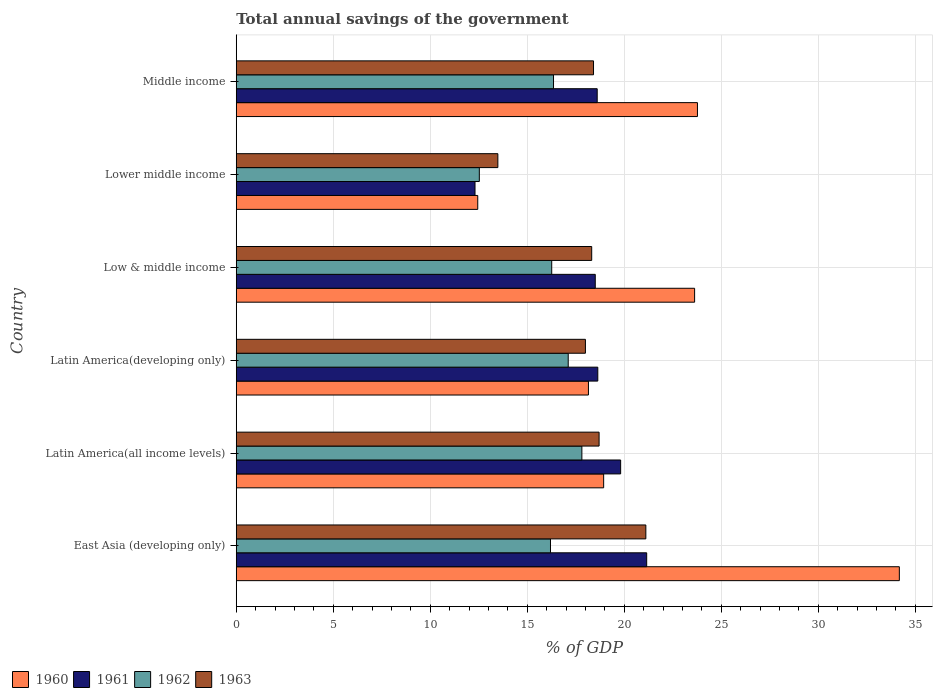How many different coloured bars are there?
Give a very brief answer. 4. How many groups of bars are there?
Offer a very short reply. 6. Are the number of bars on each tick of the Y-axis equal?
Offer a very short reply. Yes. How many bars are there on the 5th tick from the bottom?
Keep it short and to the point. 4. What is the label of the 1st group of bars from the top?
Your answer should be compact. Middle income. What is the total annual savings of the government in 1963 in East Asia (developing only)?
Your answer should be compact. 21.11. Across all countries, what is the maximum total annual savings of the government in 1960?
Give a very brief answer. 34.17. Across all countries, what is the minimum total annual savings of the government in 1960?
Give a very brief answer. 12.45. In which country was the total annual savings of the government in 1962 maximum?
Provide a succinct answer. Latin America(all income levels). In which country was the total annual savings of the government in 1962 minimum?
Make the answer very short. Lower middle income. What is the total total annual savings of the government in 1960 in the graph?
Offer a very short reply. 131.09. What is the difference between the total annual savings of the government in 1963 in Latin America(developing only) and that in Low & middle income?
Your answer should be compact. -0.32. What is the difference between the total annual savings of the government in 1960 in Middle income and the total annual savings of the government in 1962 in Low & middle income?
Make the answer very short. 7.51. What is the average total annual savings of the government in 1961 per country?
Provide a succinct answer. 18.17. What is the difference between the total annual savings of the government in 1961 and total annual savings of the government in 1960 in Low & middle income?
Make the answer very short. -5.12. In how many countries, is the total annual savings of the government in 1961 greater than 17 %?
Offer a very short reply. 5. What is the ratio of the total annual savings of the government in 1960 in Latin America(all income levels) to that in Latin America(developing only)?
Your response must be concise. 1.04. What is the difference between the highest and the second highest total annual savings of the government in 1961?
Ensure brevity in your answer.  1.34. What is the difference between the highest and the lowest total annual savings of the government in 1960?
Your response must be concise. 21.73. Is it the case that in every country, the sum of the total annual savings of the government in 1960 and total annual savings of the government in 1961 is greater than the sum of total annual savings of the government in 1962 and total annual savings of the government in 1963?
Provide a short and direct response. No. What does the 3rd bar from the top in East Asia (developing only) represents?
Ensure brevity in your answer.  1961. What does the 4th bar from the bottom in Latin America(all income levels) represents?
Your answer should be very brief. 1963. Does the graph contain any zero values?
Give a very brief answer. No. How are the legend labels stacked?
Your answer should be very brief. Horizontal. What is the title of the graph?
Offer a very short reply. Total annual savings of the government. Does "1995" appear as one of the legend labels in the graph?
Give a very brief answer. No. What is the label or title of the X-axis?
Provide a short and direct response. % of GDP. What is the label or title of the Y-axis?
Provide a succinct answer. Country. What is the % of GDP of 1960 in East Asia (developing only)?
Make the answer very short. 34.17. What is the % of GDP of 1961 in East Asia (developing only)?
Your response must be concise. 21.15. What is the % of GDP of 1962 in East Asia (developing only)?
Ensure brevity in your answer.  16.19. What is the % of GDP of 1963 in East Asia (developing only)?
Give a very brief answer. 21.11. What is the % of GDP of 1960 in Latin America(all income levels)?
Provide a short and direct response. 18.93. What is the % of GDP in 1961 in Latin America(all income levels)?
Offer a terse response. 19.81. What is the % of GDP of 1962 in Latin America(all income levels)?
Make the answer very short. 17.81. What is the % of GDP in 1963 in Latin America(all income levels)?
Offer a very short reply. 18.7. What is the % of GDP of 1960 in Latin America(developing only)?
Give a very brief answer. 18.15. What is the % of GDP in 1961 in Latin America(developing only)?
Ensure brevity in your answer.  18.63. What is the % of GDP of 1962 in Latin America(developing only)?
Offer a terse response. 17.11. What is the % of GDP in 1963 in Latin America(developing only)?
Your answer should be very brief. 17.99. What is the % of GDP of 1960 in Low & middle income?
Give a very brief answer. 23.62. What is the % of GDP of 1961 in Low & middle income?
Your answer should be very brief. 18.5. What is the % of GDP of 1962 in Low & middle income?
Offer a terse response. 16.26. What is the % of GDP of 1963 in Low & middle income?
Give a very brief answer. 18.32. What is the % of GDP in 1960 in Lower middle income?
Make the answer very short. 12.45. What is the % of GDP of 1961 in Lower middle income?
Make the answer very short. 12.3. What is the % of GDP in 1962 in Lower middle income?
Make the answer very short. 12.53. What is the % of GDP of 1963 in Lower middle income?
Offer a terse response. 13.48. What is the % of GDP of 1960 in Middle income?
Offer a terse response. 23.77. What is the % of GDP of 1961 in Middle income?
Your answer should be compact. 18.6. What is the % of GDP in 1962 in Middle income?
Offer a terse response. 16.35. What is the % of GDP in 1963 in Middle income?
Your answer should be compact. 18.41. Across all countries, what is the maximum % of GDP in 1960?
Provide a succinct answer. 34.17. Across all countries, what is the maximum % of GDP of 1961?
Provide a succinct answer. 21.15. Across all countries, what is the maximum % of GDP in 1962?
Provide a succinct answer. 17.81. Across all countries, what is the maximum % of GDP of 1963?
Give a very brief answer. 21.11. Across all countries, what is the minimum % of GDP in 1960?
Provide a short and direct response. 12.45. Across all countries, what is the minimum % of GDP in 1961?
Your answer should be very brief. 12.3. Across all countries, what is the minimum % of GDP in 1962?
Your response must be concise. 12.53. Across all countries, what is the minimum % of GDP in 1963?
Ensure brevity in your answer.  13.48. What is the total % of GDP of 1960 in the graph?
Give a very brief answer. 131.09. What is the total % of GDP of 1961 in the graph?
Your answer should be very brief. 109. What is the total % of GDP in 1962 in the graph?
Offer a terse response. 96.25. What is the total % of GDP of 1963 in the graph?
Ensure brevity in your answer.  108.02. What is the difference between the % of GDP of 1960 in East Asia (developing only) and that in Latin America(all income levels)?
Provide a short and direct response. 15.24. What is the difference between the % of GDP in 1961 in East Asia (developing only) and that in Latin America(all income levels)?
Your answer should be very brief. 1.34. What is the difference between the % of GDP of 1962 in East Asia (developing only) and that in Latin America(all income levels)?
Provide a short and direct response. -1.62. What is the difference between the % of GDP of 1963 in East Asia (developing only) and that in Latin America(all income levels)?
Provide a succinct answer. 2.41. What is the difference between the % of GDP in 1960 in East Asia (developing only) and that in Latin America(developing only)?
Your response must be concise. 16.02. What is the difference between the % of GDP in 1961 in East Asia (developing only) and that in Latin America(developing only)?
Keep it short and to the point. 2.52. What is the difference between the % of GDP of 1962 in East Asia (developing only) and that in Latin America(developing only)?
Your answer should be compact. -0.91. What is the difference between the % of GDP in 1963 in East Asia (developing only) and that in Latin America(developing only)?
Provide a succinct answer. 3.11. What is the difference between the % of GDP of 1960 in East Asia (developing only) and that in Low & middle income?
Ensure brevity in your answer.  10.55. What is the difference between the % of GDP in 1961 in East Asia (developing only) and that in Low & middle income?
Your response must be concise. 2.65. What is the difference between the % of GDP in 1962 in East Asia (developing only) and that in Low & middle income?
Ensure brevity in your answer.  -0.06. What is the difference between the % of GDP of 1963 in East Asia (developing only) and that in Low & middle income?
Your answer should be compact. 2.79. What is the difference between the % of GDP of 1960 in East Asia (developing only) and that in Lower middle income?
Offer a terse response. 21.73. What is the difference between the % of GDP in 1961 in East Asia (developing only) and that in Lower middle income?
Ensure brevity in your answer.  8.85. What is the difference between the % of GDP in 1962 in East Asia (developing only) and that in Lower middle income?
Ensure brevity in your answer.  3.67. What is the difference between the % of GDP of 1963 in East Asia (developing only) and that in Lower middle income?
Make the answer very short. 7.63. What is the difference between the % of GDP in 1960 in East Asia (developing only) and that in Middle income?
Offer a terse response. 10.4. What is the difference between the % of GDP in 1961 in East Asia (developing only) and that in Middle income?
Ensure brevity in your answer.  2.55. What is the difference between the % of GDP of 1962 in East Asia (developing only) and that in Middle income?
Make the answer very short. -0.16. What is the difference between the % of GDP in 1963 in East Asia (developing only) and that in Middle income?
Your answer should be compact. 2.7. What is the difference between the % of GDP of 1960 in Latin America(all income levels) and that in Latin America(developing only)?
Offer a terse response. 0.78. What is the difference between the % of GDP in 1961 in Latin America(all income levels) and that in Latin America(developing only)?
Keep it short and to the point. 1.18. What is the difference between the % of GDP in 1962 in Latin America(all income levels) and that in Latin America(developing only)?
Offer a very short reply. 0.7. What is the difference between the % of GDP of 1963 in Latin America(all income levels) and that in Latin America(developing only)?
Your answer should be compact. 0.7. What is the difference between the % of GDP in 1960 in Latin America(all income levels) and that in Low & middle income?
Make the answer very short. -4.69. What is the difference between the % of GDP of 1961 in Latin America(all income levels) and that in Low & middle income?
Offer a terse response. 1.31. What is the difference between the % of GDP in 1962 in Latin America(all income levels) and that in Low & middle income?
Your answer should be compact. 1.55. What is the difference between the % of GDP in 1963 in Latin America(all income levels) and that in Low & middle income?
Offer a very short reply. 0.38. What is the difference between the % of GDP in 1960 in Latin America(all income levels) and that in Lower middle income?
Make the answer very short. 6.49. What is the difference between the % of GDP in 1961 in Latin America(all income levels) and that in Lower middle income?
Your answer should be compact. 7.5. What is the difference between the % of GDP in 1962 in Latin America(all income levels) and that in Lower middle income?
Ensure brevity in your answer.  5.28. What is the difference between the % of GDP of 1963 in Latin America(all income levels) and that in Lower middle income?
Your response must be concise. 5.22. What is the difference between the % of GDP of 1960 in Latin America(all income levels) and that in Middle income?
Offer a very short reply. -4.83. What is the difference between the % of GDP in 1961 in Latin America(all income levels) and that in Middle income?
Keep it short and to the point. 1.21. What is the difference between the % of GDP of 1962 in Latin America(all income levels) and that in Middle income?
Your answer should be very brief. 1.46. What is the difference between the % of GDP in 1963 in Latin America(all income levels) and that in Middle income?
Your answer should be very brief. 0.29. What is the difference between the % of GDP in 1960 in Latin America(developing only) and that in Low & middle income?
Your response must be concise. -5.47. What is the difference between the % of GDP of 1961 in Latin America(developing only) and that in Low & middle income?
Provide a short and direct response. 0.13. What is the difference between the % of GDP in 1962 in Latin America(developing only) and that in Low & middle income?
Make the answer very short. 0.85. What is the difference between the % of GDP in 1963 in Latin America(developing only) and that in Low & middle income?
Offer a very short reply. -0.32. What is the difference between the % of GDP of 1960 in Latin America(developing only) and that in Lower middle income?
Give a very brief answer. 5.7. What is the difference between the % of GDP in 1961 in Latin America(developing only) and that in Lower middle income?
Keep it short and to the point. 6.33. What is the difference between the % of GDP in 1962 in Latin America(developing only) and that in Lower middle income?
Your response must be concise. 4.58. What is the difference between the % of GDP in 1963 in Latin America(developing only) and that in Lower middle income?
Offer a terse response. 4.51. What is the difference between the % of GDP of 1960 in Latin America(developing only) and that in Middle income?
Provide a short and direct response. -5.62. What is the difference between the % of GDP in 1961 in Latin America(developing only) and that in Middle income?
Your answer should be very brief. 0.03. What is the difference between the % of GDP of 1962 in Latin America(developing only) and that in Middle income?
Make the answer very short. 0.76. What is the difference between the % of GDP of 1963 in Latin America(developing only) and that in Middle income?
Make the answer very short. -0.42. What is the difference between the % of GDP in 1960 in Low & middle income and that in Lower middle income?
Your answer should be compact. 11.18. What is the difference between the % of GDP in 1961 in Low & middle income and that in Lower middle income?
Offer a terse response. 6.2. What is the difference between the % of GDP in 1962 in Low & middle income and that in Lower middle income?
Your answer should be very brief. 3.73. What is the difference between the % of GDP in 1963 in Low & middle income and that in Lower middle income?
Offer a very short reply. 4.84. What is the difference between the % of GDP in 1960 in Low & middle income and that in Middle income?
Offer a terse response. -0.15. What is the difference between the % of GDP in 1961 in Low & middle income and that in Middle income?
Your response must be concise. -0.1. What is the difference between the % of GDP in 1962 in Low & middle income and that in Middle income?
Provide a short and direct response. -0.09. What is the difference between the % of GDP in 1963 in Low & middle income and that in Middle income?
Give a very brief answer. -0.09. What is the difference between the % of GDP in 1960 in Lower middle income and that in Middle income?
Offer a very short reply. -11.32. What is the difference between the % of GDP of 1961 in Lower middle income and that in Middle income?
Give a very brief answer. -6.3. What is the difference between the % of GDP in 1962 in Lower middle income and that in Middle income?
Provide a short and direct response. -3.82. What is the difference between the % of GDP in 1963 in Lower middle income and that in Middle income?
Give a very brief answer. -4.93. What is the difference between the % of GDP of 1960 in East Asia (developing only) and the % of GDP of 1961 in Latin America(all income levels)?
Offer a very short reply. 14.36. What is the difference between the % of GDP of 1960 in East Asia (developing only) and the % of GDP of 1962 in Latin America(all income levels)?
Make the answer very short. 16.36. What is the difference between the % of GDP of 1960 in East Asia (developing only) and the % of GDP of 1963 in Latin America(all income levels)?
Keep it short and to the point. 15.47. What is the difference between the % of GDP in 1961 in East Asia (developing only) and the % of GDP in 1962 in Latin America(all income levels)?
Offer a very short reply. 3.34. What is the difference between the % of GDP in 1961 in East Asia (developing only) and the % of GDP in 1963 in Latin America(all income levels)?
Your response must be concise. 2.45. What is the difference between the % of GDP in 1962 in East Asia (developing only) and the % of GDP in 1963 in Latin America(all income levels)?
Provide a short and direct response. -2.5. What is the difference between the % of GDP in 1960 in East Asia (developing only) and the % of GDP in 1961 in Latin America(developing only)?
Keep it short and to the point. 15.54. What is the difference between the % of GDP of 1960 in East Asia (developing only) and the % of GDP of 1962 in Latin America(developing only)?
Provide a succinct answer. 17.06. What is the difference between the % of GDP in 1960 in East Asia (developing only) and the % of GDP in 1963 in Latin America(developing only)?
Your answer should be compact. 16.18. What is the difference between the % of GDP in 1961 in East Asia (developing only) and the % of GDP in 1962 in Latin America(developing only)?
Offer a terse response. 4.04. What is the difference between the % of GDP in 1961 in East Asia (developing only) and the % of GDP in 1963 in Latin America(developing only)?
Your answer should be very brief. 3.16. What is the difference between the % of GDP in 1962 in East Asia (developing only) and the % of GDP in 1963 in Latin America(developing only)?
Your response must be concise. -1.8. What is the difference between the % of GDP in 1960 in East Asia (developing only) and the % of GDP in 1961 in Low & middle income?
Provide a succinct answer. 15.67. What is the difference between the % of GDP of 1960 in East Asia (developing only) and the % of GDP of 1962 in Low & middle income?
Provide a short and direct response. 17.91. What is the difference between the % of GDP of 1960 in East Asia (developing only) and the % of GDP of 1963 in Low & middle income?
Your answer should be compact. 15.85. What is the difference between the % of GDP of 1961 in East Asia (developing only) and the % of GDP of 1962 in Low & middle income?
Give a very brief answer. 4.89. What is the difference between the % of GDP in 1961 in East Asia (developing only) and the % of GDP in 1963 in Low & middle income?
Provide a succinct answer. 2.83. What is the difference between the % of GDP in 1962 in East Asia (developing only) and the % of GDP in 1963 in Low & middle income?
Ensure brevity in your answer.  -2.12. What is the difference between the % of GDP of 1960 in East Asia (developing only) and the % of GDP of 1961 in Lower middle income?
Provide a short and direct response. 21.87. What is the difference between the % of GDP of 1960 in East Asia (developing only) and the % of GDP of 1962 in Lower middle income?
Offer a very short reply. 21.65. What is the difference between the % of GDP of 1960 in East Asia (developing only) and the % of GDP of 1963 in Lower middle income?
Provide a short and direct response. 20.69. What is the difference between the % of GDP of 1961 in East Asia (developing only) and the % of GDP of 1962 in Lower middle income?
Your answer should be very brief. 8.62. What is the difference between the % of GDP of 1961 in East Asia (developing only) and the % of GDP of 1963 in Lower middle income?
Your answer should be compact. 7.67. What is the difference between the % of GDP in 1962 in East Asia (developing only) and the % of GDP in 1963 in Lower middle income?
Offer a terse response. 2.71. What is the difference between the % of GDP in 1960 in East Asia (developing only) and the % of GDP in 1961 in Middle income?
Give a very brief answer. 15.57. What is the difference between the % of GDP in 1960 in East Asia (developing only) and the % of GDP in 1962 in Middle income?
Your answer should be very brief. 17.82. What is the difference between the % of GDP in 1960 in East Asia (developing only) and the % of GDP in 1963 in Middle income?
Keep it short and to the point. 15.76. What is the difference between the % of GDP of 1961 in East Asia (developing only) and the % of GDP of 1962 in Middle income?
Your answer should be compact. 4.8. What is the difference between the % of GDP of 1961 in East Asia (developing only) and the % of GDP of 1963 in Middle income?
Your response must be concise. 2.74. What is the difference between the % of GDP of 1962 in East Asia (developing only) and the % of GDP of 1963 in Middle income?
Give a very brief answer. -2.22. What is the difference between the % of GDP in 1960 in Latin America(all income levels) and the % of GDP in 1961 in Latin America(developing only)?
Your response must be concise. 0.3. What is the difference between the % of GDP in 1960 in Latin America(all income levels) and the % of GDP in 1962 in Latin America(developing only)?
Keep it short and to the point. 1.83. What is the difference between the % of GDP of 1960 in Latin America(all income levels) and the % of GDP of 1963 in Latin America(developing only)?
Provide a succinct answer. 0.94. What is the difference between the % of GDP of 1961 in Latin America(all income levels) and the % of GDP of 1962 in Latin America(developing only)?
Ensure brevity in your answer.  2.7. What is the difference between the % of GDP of 1961 in Latin America(all income levels) and the % of GDP of 1963 in Latin America(developing only)?
Give a very brief answer. 1.81. What is the difference between the % of GDP in 1962 in Latin America(all income levels) and the % of GDP in 1963 in Latin America(developing only)?
Make the answer very short. -0.18. What is the difference between the % of GDP in 1960 in Latin America(all income levels) and the % of GDP in 1961 in Low & middle income?
Offer a terse response. 0.43. What is the difference between the % of GDP of 1960 in Latin America(all income levels) and the % of GDP of 1962 in Low & middle income?
Your response must be concise. 2.68. What is the difference between the % of GDP of 1960 in Latin America(all income levels) and the % of GDP of 1963 in Low & middle income?
Your answer should be very brief. 0.62. What is the difference between the % of GDP of 1961 in Latin America(all income levels) and the % of GDP of 1962 in Low & middle income?
Offer a very short reply. 3.55. What is the difference between the % of GDP in 1961 in Latin America(all income levels) and the % of GDP in 1963 in Low & middle income?
Give a very brief answer. 1.49. What is the difference between the % of GDP of 1962 in Latin America(all income levels) and the % of GDP of 1963 in Low & middle income?
Keep it short and to the point. -0.51. What is the difference between the % of GDP of 1960 in Latin America(all income levels) and the % of GDP of 1961 in Lower middle income?
Offer a terse response. 6.63. What is the difference between the % of GDP of 1960 in Latin America(all income levels) and the % of GDP of 1962 in Lower middle income?
Ensure brevity in your answer.  6.41. What is the difference between the % of GDP in 1960 in Latin America(all income levels) and the % of GDP in 1963 in Lower middle income?
Your answer should be very brief. 5.45. What is the difference between the % of GDP in 1961 in Latin America(all income levels) and the % of GDP in 1962 in Lower middle income?
Your response must be concise. 7.28. What is the difference between the % of GDP of 1961 in Latin America(all income levels) and the % of GDP of 1963 in Lower middle income?
Your answer should be very brief. 6.33. What is the difference between the % of GDP in 1962 in Latin America(all income levels) and the % of GDP in 1963 in Lower middle income?
Offer a very short reply. 4.33. What is the difference between the % of GDP of 1960 in Latin America(all income levels) and the % of GDP of 1961 in Middle income?
Offer a very short reply. 0.33. What is the difference between the % of GDP of 1960 in Latin America(all income levels) and the % of GDP of 1962 in Middle income?
Your response must be concise. 2.58. What is the difference between the % of GDP in 1960 in Latin America(all income levels) and the % of GDP in 1963 in Middle income?
Give a very brief answer. 0.52. What is the difference between the % of GDP of 1961 in Latin America(all income levels) and the % of GDP of 1962 in Middle income?
Give a very brief answer. 3.46. What is the difference between the % of GDP in 1961 in Latin America(all income levels) and the % of GDP in 1963 in Middle income?
Make the answer very short. 1.4. What is the difference between the % of GDP of 1962 in Latin America(all income levels) and the % of GDP of 1963 in Middle income?
Provide a succinct answer. -0.6. What is the difference between the % of GDP of 1960 in Latin America(developing only) and the % of GDP of 1961 in Low & middle income?
Give a very brief answer. -0.35. What is the difference between the % of GDP in 1960 in Latin America(developing only) and the % of GDP in 1962 in Low & middle income?
Make the answer very short. 1.89. What is the difference between the % of GDP in 1960 in Latin America(developing only) and the % of GDP in 1963 in Low & middle income?
Provide a short and direct response. -0.17. What is the difference between the % of GDP in 1961 in Latin America(developing only) and the % of GDP in 1962 in Low & middle income?
Give a very brief answer. 2.37. What is the difference between the % of GDP in 1961 in Latin America(developing only) and the % of GDP in 1963 in Low & middle income?
Your answer should be very brief. 0.31. What is the difference between the % of GDP of 1962 in Latin America(developing only) and the % of GDP of 1963 in Low & middle income?
Give a very brief answer. -1.21. What is the difference between the % of GDP in 1960 in Latin America(developing only) and the % of GDP in 1961 in Lower middle income?
Offer a very short reply. 5.85. What is the difference between the % of GDP of 1960 in Latin America(developing only) and the % of GDP of 1962 in Lower middle income?
Make the answer very short. 5.62. What is the difference between the % of GDP of 1960 in Latin America(developing only) and the % of GDP of 1963 in Lower middle income?
Your answer should be very brief. 4.67. What is the difference between the % of GDP in 1961 in Latin America(developing only) and the % of GDP in 1962 in Lower middle income?
Provide a succinct answer. 6.11. What is the difference between the % of GDP of 1961 in Latin America(developing only) and the % of GDP of 1963 in Lower middle income?
Provide a short and direct response. 5.15. What is the difference between the % of GDP of 1962 in Latin America(developing only) and the % of GDP of 1963 in Lower middle income?
Give a very brief answer. 3.63. What is the difference between the % of GDP of 1960 in Latin America(developing only) and the % of GDP of 1961 in Middle income?
Offer a terse response. -0.45. What is the difference between the % of GDP in 1960 in Latin America(developing only) and the % of GDP in 1962 in Middle income?
Provide a short and direct response. 1.8. What is the difference between the % of GDP of 1960 in Latin America(developing only) and the % of GDP of 1963 in Middle income?
Ensure brevity in your answer.  -0.26. What is the difference between the % of GDP in 1961 in Latin America(developing only) and the % of GDP in 1962 in Middle income?
Offer a very short reply. 2.28. What is the difference between the % of GDP of 1961 in Latin America(developing only) and the % of GDP of 1963 in Middle income?
Give a very brief answer. 0.22. What is the difference between the % of GDP of 1962 in Latin America(developing only) and the % of GDP of 1963 in Middle income?
Ensure brevity in your answer.  -1.3. What is the difference between the % of GDP in 1960 in Low & middle income and the % of GDP in 1961 in Lower middle income?
Ensure brevity in your answer.  11.32. What is the difference between the % of GDP of 1960 in Low & middle income and the % of GDP of 1962 in Lower middle income?
Provide a succinct answer. 11.09. What is the difference between the % of GDP of 1960 in Low & middle income and the % of GDP of 1963 in Lower middle income?
Your answer should be compact. 10.14. What is the difference between the % of GDP of 1961 in Low & middle income and the % of GDP of 1962 in Lower middle income?
Your answer should be compact. 5.97. What is the difference between the % of GDP of 1961 in Low & middle income and the % of GDP of 1963 in Lower middle income?
Ensure brevity in your answer.  5.02. What is the difference between the % of GDP of 1962 in Low & middle income and the % of GDP of 1963 in Lower middle income?
Provide a succinct answer. 2.78. What is the difference between the % of GDP in 1960 in Low & middle income and the % of GDP in 1961 in Middle income?
Make the answer very short. 5.02. What is the difference between the % of GDP of 1960 in Low & middle income and the % of GDP of 1962 in Middle income?
Offer a very short reply. 7.27. What is the difference between the % of GDP in 1960 in Low & middle income and the % of GDP in 1963 in Middle income?
Keep it short and to the point. 5.21. What is the difference between the % of GDP in 1961 in Low & middle income and the % of GDP in 1962 in Middle income?
Offer a very short reply. 2.15. What is the difference between the % of GDP in 1961 in Low & middle income and the % of GDP in 1963 in Middle income?
Offer a very short reply. 0.09. What is the difference between the % of GDP in 1962 in Low & middle income and the % of GDP in 1963 in Middle income?
Your response must be concise. -2.15. What is the difference between the % of GDP in 1960 in Lower middle income and the % of GDP in 1961 in Middle income?
Your response must be concise. -6.16. What is the difference between the % of GDP in 1960 in Lower middle income and the % of GDP in 1962 in Middle income?
Make the answer very short. -3.9. What is the difference between the % of GDP in 1960 in Lower middle income and the % of GDP in 1963 in Middle income?
Provide a short and direct response. -5.97. What is the difference between the % of GDP in 1961 in Lower middle income and the % of GDP in 1962 in Middle income?
Offer a terse response. -4.05. What is the difference between the % of GDP of 1961 in Lower middle income and the % of GDP of 1963 in Middle income?
Your answer should be very brief. -6.11. What is the difference between the % of GDP in 1962 in Lower middle income and the % of GDP in 1963 in Middle income?
Offer a very short reply. -5.88. What is the average % of GDP in 1960 per country?
Keep it short and to the point. 21.85. What is the average % of GDP in 1961 per country?
Ensure brevity in your answer.  18.17. What is the average % of GDP in 1962 per country?
Offer a terse response. 16.04. What is the average % of GDP in 1963 per country?
Give a very brief answer. 18. What is the difference between the % of GDP of 1960 and % of GDP of 1961 in East Asia (developing only)?
Make the answer very short. 13.02. What is the difference between the % of GDP of 1960 and % of GDP of 1962 in East Asia (developing only)?
Keep it short and to the point. 17.98. What is the difference between the % of GDP of 1960 and % of GDP of 1963 in East Asia (developing only)?
Offer a terse response. 13.06. What is the difference between the % of GDP of 1961 and % of GDP of 1962 in East Asia (developing only)?
Provide a succinct answer. 4.96. What is the difference between the % of GDP of 1961 and % of GDP of 1963 in East Asia (developing only)?
Offer a terse response. 0.04. What is the difference between the % of GDP in 1962 and % of GDP in 1963 in East Asia (developing only)?
Provide a succinct answer. -4.91. What is the difference between the % of GDP in 1960 and % of GDP in 1961 in Latin America(all income levels)?
Your answer should be very brief. -0.87. What is the difference between the % of GDP of 1960 and % of GDP of 1962 in Latin America(all income levels)?
Provide a succinct answer. 1.12. What is the difference between the % of GDP of 1960 and % of GDP of 1963 in Latin America(all income levels)?
Your answer should be compact. 0.24. What is the difference between the % of GDP of 1961 and % of GDP of 1962 in Latin America(all income levels)?
Your response must be concise. 2. What is the difference between the % of GDP of 1961 and % of GDP of 1963 in Latin America(all income levels)?
Give a very brief answer. 1.11. What is the difference between the % of GDP in 1962 and % of GDP in 1963 in Latin America(all income levels)?
Provide a short and direct response. -0.89. What is the difference between the % of GDP in 1960 and % of GDP in 1961 in Latin America(developing only)?
Make the answer very short. -0.48. What is the difference between the % of GDP of 1960 and % of GDP of 1962 in Latin America(developing only)?
Make the answer very short. 1.04. What is the difference between the % of GDP of 1960 and % of GDP of 1963 in Latin America(developing only)?
Offer a very short reply. 0.16. What is the difference between the % of GDP in 1961 and % of GDP in 1962 in Latin America(developing only)?
Offer a terse response. 1.52. What is the difference between the % of GDP of 1961 and % of GDP of 1963 in Latin America(developing only)?
Provide a short and direct response. 0.64. What is the difference between the % of GDP in 1962 and % of GDP in 1963 in Latin America(developing only)?
Give a very brief answer. -0.89. What is the difference between the % of GDP in 1960 and % of GDP in 1961 in Low & middle income?
Provide a short and direct response. 5.12. What is the difference between the % of GDP in 1960 and % of GDP in 1962 in Low & middle income?
Make the answer very short. 7.36. What is the difference between the % of GDP in 1960 and % of GDP in 1963 in Low & middle income?
Make the answer very short. 5.3. What is the difference between the % of GDP of 1961 and % of GDP of 1962 in Low & middle income?
Make the answer very short. 2.24. What is the difference between the % of GDP of 1961 and % of GDP of 1963 in Low & middle income?
Provide a short and direct response. 0.18. What is the difference between the % of GDP in 1962 and % of GDP in 1963 in Low & middle income?
Offer a very short reply. -2.06. What is the difference between the % of GDP of 1960 and % of GDP of 1961 in Lower middle income?
Give a very brief answer. 0.14. What is the difference between the % of GDP of 1960 and % of GDP of 1962 in Lower middle income?
Offer a very short reply. -0.08. What is the difference between the % of GDP in 1960 and % of GDP in 1963 in Lower middle income?
Ensure brevity in your answer.  -1.04. What is the difference between the % of GDP of 1961 and % of GDP of 1962 in Lower middle income?
Make the answer very short. -0.22. What is the difference between the % of GDP of 1961 and % of GDP of 1963 in Lower middle income?
Ensure brevity in your answer.  -1.18. What is the difference between the % of GDP of 1962 and % of GDP of 1963 in Lower middle income?
Provide a succinct answer. -0.95. What is the difference between the % of GDP in 1960 and % of GDP in 1961 in Middle income?
Your answer should be compact. 5.17. What is the difference between the % of GDP in 1960 and % of GDP in 1962 in Middle income?
Ensure brevity in your answer.  7.42. What is the difference between the % of GDP of 1960 and % of GDP of 1963 in Middle income?
Your response must be concise. 5.36. What is the difference between the % of GDP of 1961 and % of GDP of 1962 in Middle income?
Your answer should be compact. 2.25. What is the difference between the % of GDP of 1961 and % of GDP of 1963 in Middle income?
Your answer should be very brief. 0.19. What is the difference between the % of GDP in 1962 and % of GDP in 1963 in Middle income?
Make the answer very short. -2.06. What is the ratio of the % of GDP in 1960 in East Asia (developing only) to that in Latin America(all income levels)?
Give a very brief answer. 1.8. What is the ratio of the % of GDP of 1961 in East Asia (developing only) to that in Latin America(all income levels)?
Offer a very short reply. 1.07. What is the ratio of the % of GDP of 1962 in East Asia (developing only) to that in Latin America(all income levels)?
Offer a terse response. 0.91. What is the ratio of the % of GDP of 1963 in East Asia (developing only) to that in Latin America(all income levels)?
Your answer should be compact. 1.13. What is the ratio of the % of GDP in 1960 in East Asia (developing only) to that in Latin America(developing only)?
Offer a very short reply. 1.88. What is the ratio of the % of GDP of 1961 in East Asia (developing only) to that in Latin America(developing only)?
Provide a short and direct response. 1.14. What is the ratio of the % of GDP of 1962 in East Asia (developing only) to that in Latin America(developing only)?
Give a very brief answer. 0.95. What is the ratio of the % of GDP of 1963 in East Asia (developing only) to that in Latin America(developing only)?
Offer a terse response. 1.17. What is the ratio of the % of GDP of 1960 in East Asia (developing only) to that in Low & middle income?
Make the answer very short. 1.45. What is the ratio of the % of GDP of 1961 in East Asia (developing only) to that in Low & middle income?
Keep it short and to the point. 1.14. What is the ratio of the % of GDP of 1963 in East Asia (developing only) to that in Low & middle income?
Give a very brief answer. 1.15. What is the ratio of the % of GDP in 1960 in East Asia (developing only) to that in Lower middle income?
Offer a terse response. 2.75. What is the ratio of the % of GDP of 1961 in East Asia (developing only) to that in Lower middle income?
Ensure brevity in your answer.  1.72. What is the ratio of the % of GDP of 1962 in East Asia (developing only) to that in Lower middle income?
Offer a terse response. 1.29. What is the ratio of the % of GDP of 1963 in East Asia (developing only) to that in Lower middle income?
Ensure brevity in your answer.  1.57. What is the ratio of the % of GDP in 1960 in East Asia (developing only) to that in Middle income?
Ensure brevity in your answer.  1.44. What is the ratio of the % of GDP of 1961 in East Asia (developing only) to that in Middle income?
Provide a short and direct response. 1.14. What is the ratio of the % of GDP in 1963 in East Asia (developing only) to that in Middle income?
Give a very brief answer. 1.15. What is the ratio of the % of GDP in 1960 in Latin America(all income levels) to that in Latin America(developing only)?
Give a very brief answer. 1.04. What is the ratio of the % of GDP of 1961 in Latin America(all income levels) to that in Latin America(developing only)?
Give a very brief answer. 1.06. What is the ratio of the % of GDP in 1962 in Latin America(all income levels) to that in Latin America(developing only)?
Provide a short and direct response. 1.04. What is the ratio of the % of GDP of 1963 in Latin America(all income levels) to that in Latin America(developing only)?
Provide a succinct answer. 1.04. What is the ratio of the % of GDP of 1960 in Latin America(all income levels) to that in Low & middle income?
Provide a short and direct response. 0.8. What is the ratio of the % of GDP of 1961 in Latin America(all income levels) to that in Low & middle income?
Give a very brief answer. 1.07. What is the ratio of the % of GDP in 1962 in Latin America(all income levels) to that in Low & middle income?
Provide a succinct answer. 1.1. What is the ratio of the % of GDP of 1963 in Latin America(all income levels) to that in Low & middle income?
Offer a terse response. 1.02. What is the ratio of the % of GDP of 1960 in Latin America(all income levels) to that in Lower middle income?
Your answer should be compact. 1.52. What is the ratio of the % of GDP in 1961 in Latin America(all income levels) to that in Lower middle income?
Offer a terse response. 1.61. What is the ratio of the % of GDP in 1962 in Latin America(all income levels) to that in Lower middle income?
Your response must be concise. 1.42. What is the ratio of the % of GDP in 1963 in Latin America(all income levels) to that in Lower middle income?
Give a very brief answer. 1.39. What is the ratio of the % of GDP in 1960 in Latin America(all income levels) to that in Middle income?
Ensure brevity in your answer.  0.8. What is the ratio of the % of GDP in 1961 in Latin America(all income levels) to that in Middle income?
Keep it short and to the point. 1.06. What is the ratio of the % of GDP in 1962 in Latin America(all income levels) to that in Middle income?
Offer a very short reply. 1.09. What is the ratio of the % of GDP in 1963 in Latin America(all income levels) to that in Middle income?
Provide a short and direct response. 1.02. What is the ratio of the % of GDP of 1960 in Latin America(developing only) to that in Low & middle income?
Offer a terse response. 0.77. What is the ratio of the % of GDP of 1961 in Latin America(developing only) to that in Low & middle income?
Offer a terse response. 1.01. What is the ratio of the % of GDP in 1962 in Latin America(developing only) to that in Low & middle income?
Your response must be concise. 1.05. What is the ratio of the % of GDP in 1963 in Latin America(developing only) to that in Low & middle income?
Your answer should be compact. 0.98. What is the ratio of the % of GDP in 1960 in Latin America(developing only) to that in Lower middle income?
Your response must be concise. 1.46. What is the ratio of the % of GDP of 1961 in Latin America(developing only) to that in Lower middle income?
Offer a terse response. 1.51. What is the ratio of the % of GDP in 1962 in Latin America(developing only) to that in Lower middle income?
Your answer should be very brief. 1.37. What is the ratio of the % of GDP of 1963 in Latin America(developing only) to that in Lower middle income?
Offer a very short reply. 1.33. What is the ratio of the % of GDP of 1960 in Latin America(developing only) to that in Middle income?
Your response must be concise. 0.76. What is the ratio of the % of GDP of 1961 in Latin America(developing only) to that in Middle income?
Keep it short and to the point. 1. What is the ratio of the % of GDP in 1962 in Latin America(developing only) to that in Middle income?
Ensure brevity in your answer.  1.05. What is the ratio of the % of GDP of 1963 in Latin America(developing only) to that in Middle income?
Provide a short and direct response. 0.98. What is the ratio of the % of GDP in 1960 in Low & middle income to that in Lower middle income?
Give a very brief answer. 1.9. What is the ratio of the % of GDP of 1961 in Low & middle income to that in Lower middle income?
Your answer should be compact. 1.5. What is the ratio of the % of GDP in 1962 in Low & middle income to that in Lower middle income?
Keep it short and to the point. 1.3. What is the ratio of the % of GDP of 1963 in Low & middle income to that in Lower middle income?
Offer a very short reply. 1.36. What is the ratio of the % of GDP of 1960 in Low & middle income to that in Middle income?
Provide a succinct answer. 0.99. What is the ratio of the % of GDP in 1962 in Low & middle income to that in Middle income?
Your answer should be compact. 0.99. What is the ratio of the % of GDP in 1960 in Lower middle income to that in Middle income?
Offer a terse response. 0.52. What is the ratio of the % of GDP of 1961 in Lower middle income to that in Middle income?
Your answer should be very brief. 0.66. What is the ratio of the % of GDP of 1962 in Lower middle income to that in Middle income?
Your response must be concise. 0.77. What is the ratio of the % of GDP in 1963 in Lower middle income to that in Middle income?
Your response must be concise. 0.73. What is the difference between the highest and the second highest % of GDP of 1960?
Ensure brevity in your answer.  10.4. What is the difference between the highest and the second highest % of GDP of 1961?
Keep it short and to the point. 1.34. What is the difference between the highest and the second highest % of GDP of 1962?
Your response must be concise. 0.7. What is the difference between the highest and the second highest % of GDP in 1963?
Your answer should be compact. 2.41. What is the difference between the highest and the lowest % of GDP in 1960?
Provide a short and direct response. 21.73. What is the difference between the highest and the lowest % of GDP of 1961?
Make the answer very short. 8.85. What is the difference between the highest and the lowest % of GDP of 1962?
Provide a short and direct response. 5.28. What is the difference between the highest and the lowest % of GDP in 1963?
Your answer should be compact. 7.63. 